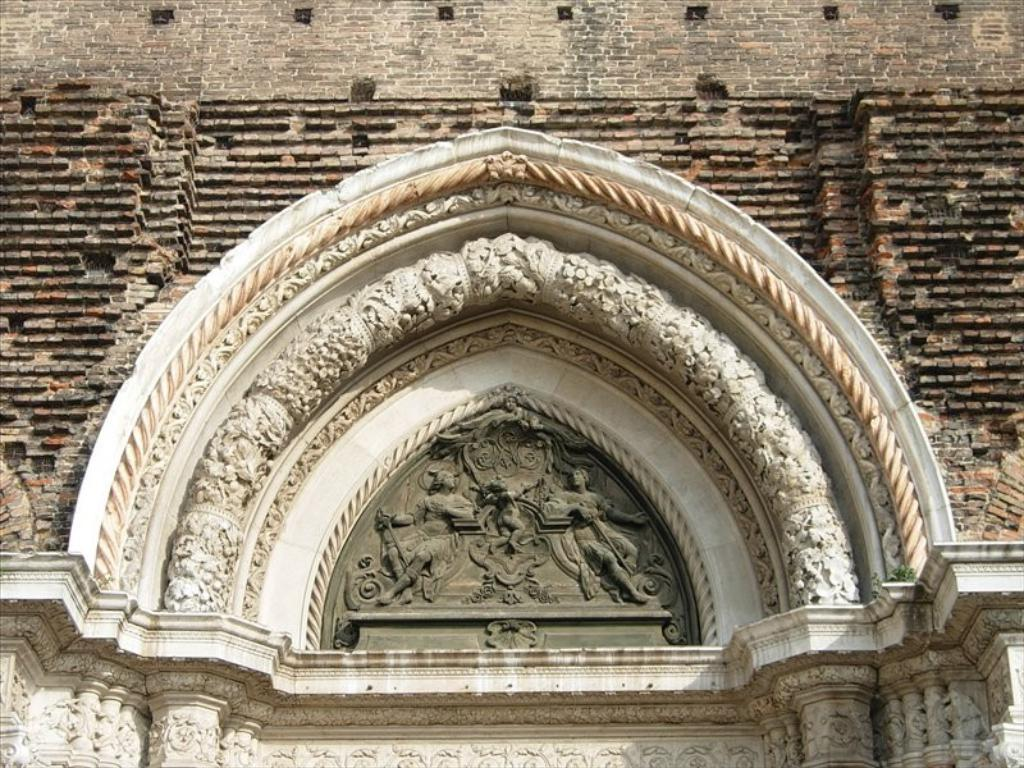What is the main subject of the image? The main subject of the image is a part of a building. What can be observed on the building's exterior? The building has carvings on the wall. How many beds are visible in the image? There are no beds present in the image; it features a part of a building with carvings on the wall. What is the limit of the carvings on the building's wall? The facts provided do not give information about the extent or limit of the carvings on the building's wall. 